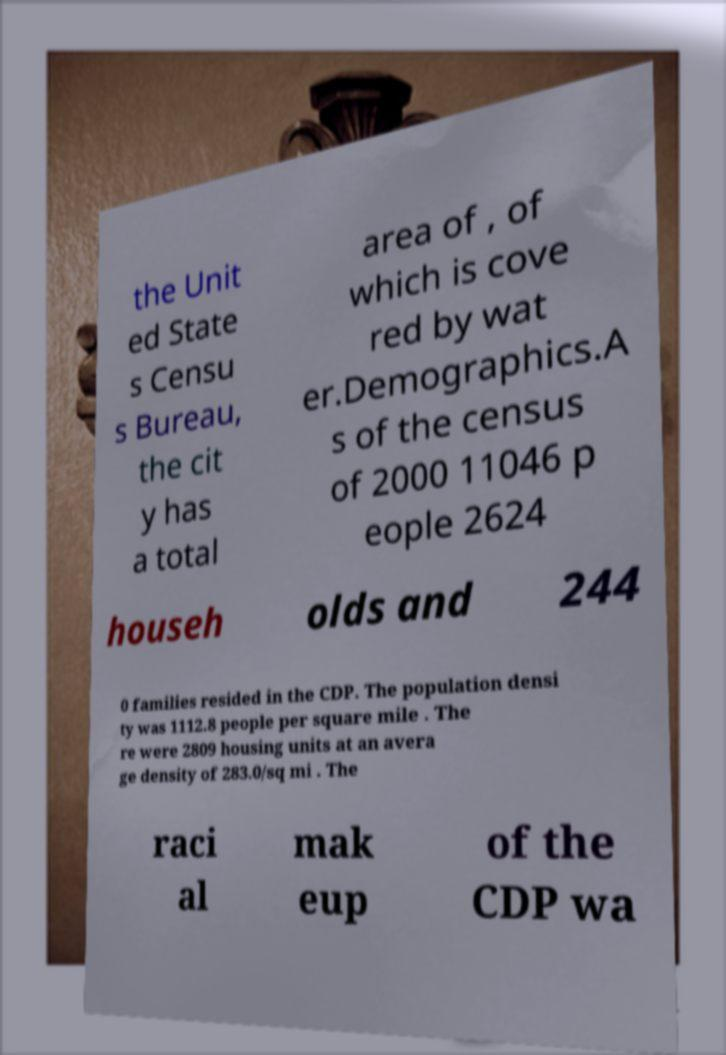Could you assist in decoding the text presented in this image and type it out clearly? the Unit ed State s Censu s Bureau, the cit y has a total area of , of which is cove red by wat er.Demographics.A s of the census of 2000 11046 p eople 2624 househ olds and 244 0 families resided in the CDP. The population densi ty was 1112.8 people per square mile . The re were 2809 housing units at an avera ge density of 283.0/sq mi . The raci al mak eup of the CDP wa 